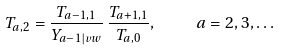<formula> <loc_0><loc_0><loc_500><loc_500>T _ { a , 2 } = \frac { T _ { a - 1 , 1 } } { Y _ { a - 1 | v w } } \, \frac { T _ { a + 1 , 1 } } { T _ { a , 0 } } , \quad a = 2 , 3 , \dots</formula> 